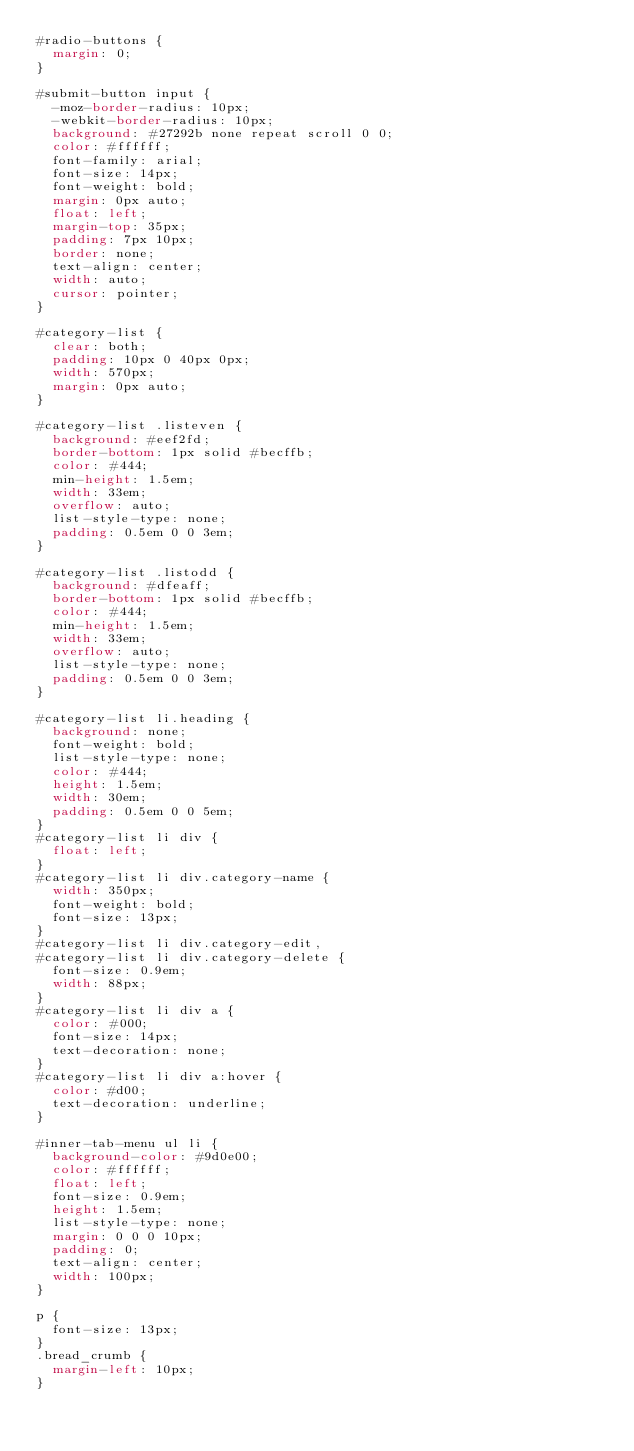Convert code to text. <code><loc_0><loc_0><loc_500><loc_500><_CSS_>#radio-buttons {
  margin: 0;
}

#submit-button input {
  -moz-border-radius: 10px;
  -webkit-border-radius: 10px;
  background: #27292b none repeat scroll 0 0;
  color: #ffffff;
  font-family: arial;
  font-size: 14px;
  font-weight: bold;
  margin: 0px auto;
  float: left;
  margin-top: 35px;
  padding: 7px 10px;
  border: none;
  text-align: center;
  width: auto;
  cursor: pointer;
}

#category-list {
  clear: both;
  padding: 10px 0 40px 0px;
  width: 570px;
  margin: 0px auto;
}

#category-list .listeven {
  background: #eef2fd;
  border-bottom: 1px solid #becffb;
  color: #444;
  min-height: 1.5em;
  width: 33em;
  overflow: auto;
  list-style-type: none;
  padding: 0.5em 0 0 3em;
}

#category-list .listodd {
  background: #dfeaff;
  border-bottom: 1px solid #becffb;
  color: #444;
  min-height: 1.5em;
  width: 33em;
  overflow: auto;
  list-style-type: none;
  padding: 0.5em 0 0 3em;
}

#category-list li.heading {
  background: none;
  font-weight: bold;
  list-style-type: none;
  color: #444;
  height: 1.5em;
  width: 30em;
  padding: 0.5em 0 0 5em;
}
#category-list li div {
  float: left;
}
#category-list li div.category-name {
  width: 350px;
  font-weight: bold;
  font-size: 13px;
}
#category-list li div.category-edit,
#category-list li div.category-delete {
  font-size: 0.9em;
  width: 88px;
}
#category-list li div a {
  color: #000;
  font-size: 14px;
  text-decoration: none;
}
#category-list li div a:hover {
  color: #d00;
  text-decoration: underline;
}

#inner-tab-menu ul li {
  background-color: #9d0e00;
  color: #ffffff;
  float: left;
  font-size: 0.9em;
  height: 1.5em;
  list-style-type: none;
  margin: 0 0 0 10px;
  padding: 0;
  text-align: center;
  width: 100px;
}

p {
  font-size: 13px;
}
.bread_crumb {
  margin-left: 10px;
}
</code> 